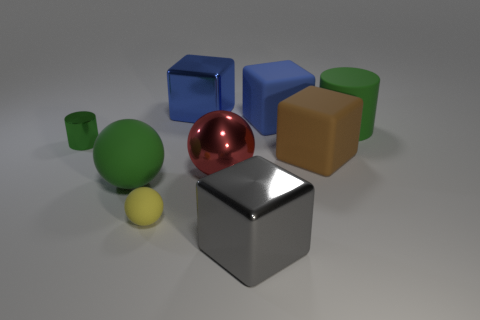How many big brown rubber objects are to the right of the tiny matte thing?
Provide a succinct answer. 1. What is the size of the other green object that is the same shape as the small green thing?
Offer a very short reply. Large. How many green objects are either large things or big blocks?
Offer a terse response. 2. What number of big green matte things are to the left of the metal block that is in front of the big brown rubber cube?
Your answer should be very brief. 1. What number of other objects are there of the same shape as the small yellow matte thing?
Offer a terse response. 2. There is a big cylinder that is the same color as the small cylinder; what is its material?
Offer a terse response. Rubber. What number of big matte blocks are the same color as the rubber cylinder?
Provide a short and direct response. 0. What is the color of the cylinder that is made of the same material as the green ball?
Keep it short and to the point. Green. Are there any gray matte cylinders of the same size as the brown matte object?
Your answer should be very brief. No. Is the number of large matte cylinders that are behind the large green ball greater than the number of big metal blocks that are in front of the large red object?
Provide a short and direct response. No. 